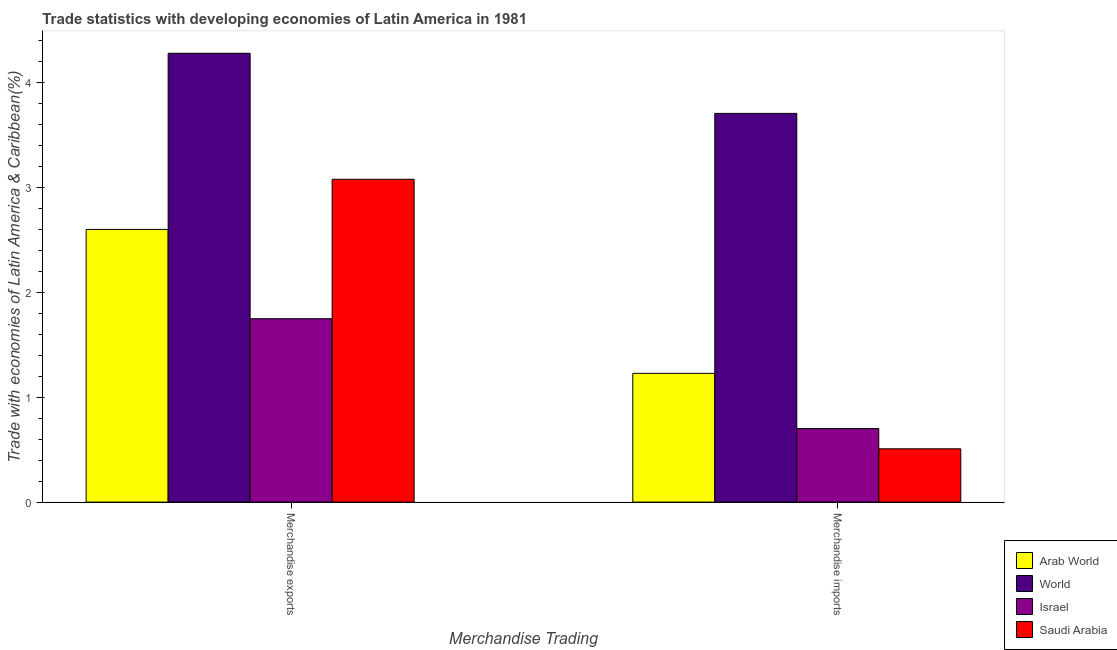How many different coloured bars are there?
Ensure brevity in your answer.  4. Are the number of bars per tick equal to the number of legend labels?
Provide a succinct answer. Yes. What is the merchandise exports in World?
Make the answer very short. 4.28. Across all countries, what is the maximum merchandise exports?
Give a very brief answer. 4.28. Across all countries, what is the minimum merchandise imports?
Your answer should be very brief. 0.51. In which country was the merchandise exports minimum?
Provide a succinct answer. Israel. What is the total merchandise exports in the graph?
Provide a short and direct response. 11.71. What is the difference between the merchandise imports in Arab World and that in World?
Keep it short and to the point. -2.48. What is the difference between the merchandise imports in Saudi Arabia and the merchandise exports in World?
Make the answer very short. -3.77. What is the average merchandise imports per country?
Give a very brief answer. 1.54. What is the difference between the merchandise exports and merchandise imports in World?
Your response must be concise. 0.57. What is the ratio of the merchandise exports in Saudi Arabia to that in World?
Provide a short and direct response. 0.72. In how many countries, is the merchandise imports greater than the average merchandise imports taken over all countries?
Your answer should be very brief. 1. What does the 3rd bar from the right in Merchandise exports represents?
Your answer should be compact. World. How many bars are there?
Keep it short and to the point. 8. How many countries are there in the graph?
Provide a succinct answer. 4. What is the difference between two consecutive major ticks on the Y-axis?
Your response must be concise. 1. Does the graph contain grids?
Offer a very short reply. No. What is the title of the graph?
Your answer should be compact. Trade statistics with developing economies of Latin America in 1981. What is the label or title of the X-axis?
Ensure brevity in your answer.  Merchandise Trading. What is the label or title of the Y-axis?
Your answer should be very brief. Trade with economies of Latin America & Caribbean(%). What is the Trade with economies of Latin America & Caribbean(%) of Arab World in Merchandise exports?
Make the answer very short. 2.6. What is the Trade with economies of Latin America & Caribbean(%) of World in Merchandise exports?
Provide a succinct answer. 4.28. What is the Trade with economies of Latin America & Caribbean(%) of Israel in Merchandise exports?
Provide a short and direct response. 1.75. What is the Trade with economies of Latin America & Caribbean(%) in Saudi Arabia in Merchandise exports?
Make the answer very short. 3.08. What is the Trade with economies of Latin America & Caribbean(%) in Arab World in Merchandise imports?
Ensure brevity in your answer.  1.23. What is the Trade with economies of Latin America & Caribbean(%) in World in Merchandise imports?
Your answer should be very brief. 3.71. What is the Trade with economies of Latin America & Caribbean(%) of Israel in Merchandise imports?
Your response must be concise. 0.7. What is the Trade with economies of Latin America & Caribbean(%) in Saudi Arabia in Merchandise imports?
Give a very brief answer. 0.51. Across all Merchandise Trading, what is the maximum Trade with economies of Latin America & Caribbean(%) of Arab World?
Your answer should be compact. 2.6. Across all Merchandise Trading, what is the maximum Trade with economies of Latin America & Caribbean(%) of World?
Provide a succinct answer. 4.28. Across all Merchandise Trading, what is the maximum Trade with economies of Latin America & Caribbean(%) in Israel?
Provide a short and direct response. 1.75. Across all Merchandise Trading, what is the maximum Trade with economies of Latin America & Caribbean(%) in Saudi Arabia?
Your answer should be compact. 3.08. Across all Merchandise Trading, what is the minimum Trade with economies of Latin America & Caribbean(%) in Arab World?
Ensure brevity in your answer.  1.23. Across all Merchandise Trading, what is the minimum Trade with economies of Latin America & Caribbean(%) of World?
Ensure brevity in your answer.  3.71. Across all Merchandise Trading, what is the minimum Trade with economies of Latin America & Caribbean(%) in Israel?
Provide a succinct answer. 0.7. Across all Merchandise Trading, what is the minimum Trade with economies of Latin America & Caribbean(%) of Saudi Arabia?
Keep it short and to the point. 0.51. What is the total Trade with economies of Latin America & Caribbean(%) of Arab World in the graph?
Give a very brief answer. 3.83. What is the total Trade with economies of Latin America & Caribbean(%) in World in the graph?
Keep it short and to the point. 7.99. What is the total Trade with economies of Latin America & Caribbean(%) of Israel in the graph?
Your response must be concise. 2.45. What is the total Trade with economies of Latin America & Caribbean(%) in Saudi Arabia in the graph?
Offer a very short reply. 3.59. What is the difference between the Trade with economies of Latin America & Caribbean(%) of Arab World in Merchandise exports and that in Merchandise imports?
Keep it short and to the point. 1.37. What is the difference between the Trade with economies of Latin America & Caribbean(%) of World in Merchandise exports and that in Merchandise imports?
Provide a succinct answer. 0.57. What is the difference between the Trade with economies of Latin America & Caribbean(%) in Israel in Merchandise exports and that in Merchandise imports?
Keep it short and to the point. 1.05. What is the difference between the Trade with economies of Latin America & Caribbean(%) of Saudi Arabia in Merchandise exports and that in Merchandise imports?
Offer a very short reply. 2.57. What is the difference between the Trade with economies of Latin America & Caribbean(%) in Arab World in Merchandise exports and the Trade with economies of Latin America & Caribbean(%) in World in Merchandise imports?
Give a very brief answer. -1.11. What is the difference between the Trade with economies of Latin America & Caribbean(%) in Arab World in Merchandise exports and the Trade with economies of Latin America & Caribbean(%) in Israel in Merchandise imports?
Provide a succinct answer. 1.9. What is the difference between the Trade with economies of Latin America & Caribbean(%) in Arab World in Merchandise exports and the Trade with economies of Latin America & Caribbean(%) in Saudi Arabia in Merchandise imports?
Offer a terse response. 2.09. What is the difference between the Trade with economies of Latin America & Caribbean(%) of World in Merchandise exports and the Trade with economies of Latin America & Caribbean(%) of Israel in Merchandise imports?
Offer a very short reply. 3.58. What is the difference between the Trade with economies of Latin America & Caribbean(%) in World in Merchandise exports and the Trade with economies of Latin America & Caribbean(%) in Saudi Arabia in Merchandise imports?
Offer a very short reply. 3.77. What is the difference between the Trade with economies of Latin America & Caribbean(%) in Israel in Merchandise exports and the Trade with economies of Latin America & Caribbean(%) in Saudi Arabia in Merchandise imports?
Give a very brief answer. 1.24. What is the average Trade with economies of Latin America & Caribbean(%) of Arab World per Merchandise Trading?
Provide a succinct answer. 1.91. What is the average Trade with economies of Latin America & Caribbean(%) in World per Merchandise Trading?
Your answer should be compact. 3.99. What is the average Trade with economies of Latin America & Caribbean(%) of Israel per Merchandise Trading?
Your response must be concise. 1.23. What is the average Trade with economies of Latin America & Caribbean(%) of Saudi Arabia per Merchandise Trading?
Provide a short and direct response. 1.79. What is the difference between the Trade with economies of Latin America & Caribbean(%) of Arab World and Trade with economies of Latin America & Caribbean(%) of World in Merchandise exports?
Ensure brevity in your answer.  -1.68. What is the difference between the Trade with economies of Latin America & Caribbean(%) of Arab World and Trade with economies of Latin America & Caribbean(%) of Israel in Merchandise exports?
Give a very brief answer. 0.85. What is the difference between the Trade with economies of Latin America & Caribbean(%) of Arab World and Trade with economies of Latin America & Caribbean(%) of Saudi Arabia in Merchandise exports?
Offer a terse response. -0.48. What is the difference between the Trade with economies of Latin America & Caribbean(%) of World and Trade with economies of Latin America & Caribbean(%) of Israel in Merchandise exports?
Keep it short and to the point. 2.53. What is the difference between the Trade with economies of Latin America & Caribbean(%) of World and Trade with economies of Latin America & Caribbean(%) of Saudi Arabia in Merchandise exports?
Your response must be concise. 1.2. What is the difference between the Trade with economies of Latin America & Caribbean(%) of Israel and Trade with economies of Latin America & Caribbean(%) of Saudi Arabia in Merchandise exports?
Your answer should be very brief. -1.33. What is the difference between the Trade with economies of Latin America & Caribbean(%) in Arab World and Trade with economies of Latin America & Caribbean(%) in World in Merchandise imports?
Your response must be concise. -2.48. What is the difference between the Trade with economies of Latin America & Caribbean(%) in Arab World and Trade with economies of Latin America & Caribbean(%) in Israel in Merchandise imports?
Your answer should be very brief. 0.53. What is the difference between the Trade with economies of Latin America & Caribbean(%) of Arab World and Trade with economies of Latin America & Caribbean(%) of Saudi Arabia in Merchandise imports?
Provide a succinct answer. 0.72. What is the difference between the Trade with economies of Latin America & Caribbean(%) of World and Trade with economies of Latin America & Caribbean(%) of Israel in Merchandise imports?
Provide a short and direct response. 3. What is the difference between the Trade with economies of Latin America & Caribbean(%) of World and Trade with economies of Latin America & Caribbean(%) of Saudi Arabia in Merchandise imports?
Offer a very short reply. 3.2. What is the difference between the Trade with economies of Latin America & Caribbean(%) of Israel and Trade with economies of Latin America & Caribbean(%) of Saudi Arabia in Merchandise imports?
Your answer should be very brief. 0.19. What is the ratio of the Trade with economies of Latin America & Caribbean(%) in Arab World in Merchandise exports to that in Merchandise imports?
Your response must be concise. 2.12. What is the ratio of the Trade with economies of Latin America & Caribbean(%) in World in Merchandise exports to that in Merchandise imports?
Your answer should be very brief. 1.15. What is the ratio of the Trade with economies of Latin America & Caribbean(%) of Israel in Merchandise exports to that in Merchandise imports?
Your answer should be compact. 2.49. What is the ratio of the Trade with economies of Latin America & Caribbean(%) in Saudi Arabia in Merchandise exports to that in Merchandise imports?
Offer a very short reply. 6.06. What is the difference between the highest and the second highest Trade with economies of Latin America & Caribbean(%) of Arab World?
Your response must be concise. 1.37. What is the difference between the highest and the second highest Trade with economies of Latin America & Caribbean(%) of World?
Offer a terse response. 0.57. What is the difference between the highest and the second highest Trade with economies of Latin America & Caribbean(%) of Israel?
Keep it short and to the point. 1.05. What is the difference between the highest and the second highest Trade with economies of Latin America & Caribbean(%) of Saudi Arabia?
Give a very brief answer. 2.57. What is the difference between the highest and the lowest Trade with economies of Latin America & Caribbean(%) in Arab World?
Make the answer very short. 1.37. What is the difference between the highest and the lowest Trade with economies of Latin America & Caribbean(%) in World?
Provide a short and direct response. 0.57. What is the difference between the highest and the lowest Trade with economies of Latin America & Caribbean(%) in Israel?
Give a very brief answer. 1.05. What is the difference between the highest and the lowest Trade with economies of Latin America & Caribbean(%) in Saudi Arabia?
Give a very brief answer. 2.57. 